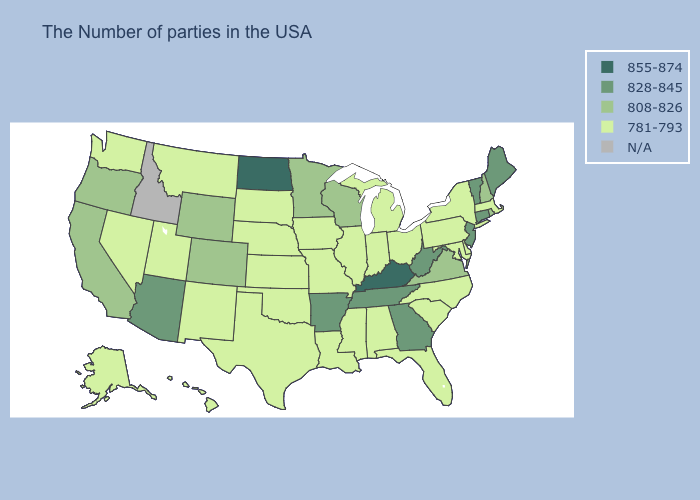Name the states that have a value in the range 828-845?
Give a very brief answer. Maine, Vermont, Connecticut, New Jersey, West Virginia, Georgia, Tennessee, Arkansas, Arizona. What is the value of New York?
Quick response, please. 781-793. Does Kentucky have the highest value in the South?
Write a very short answer. Yes. What is the highest value in states that border Georgia?
Write a very short answer. 828-845. Name the states that have a value in the range N/A?
Give a very brief answer. Idaho. What is the value of Colorado?
Answer briefly. 808-826. Name the states that have a value in the range 855-874?
Give a very brief answer. Kentucky, North Dakota. Is the legend a continuous bar?
Be succinct. No. Among the states that border West Virginia , which have the highest value?
Give a very brief answer. Kentucky. What is the value of Illinois?
Be succinct. 781-793. What is the value of Maryland?
Short answer required. 781-793. Does South Carolina have the highest value in the USA?
Be succinct. No. What is the lowest value in the West?
Give a very brief answer. 781-793. Name the states that have a value in the range 855-874?
Answer briefly. Kentucky, North Dakota. 